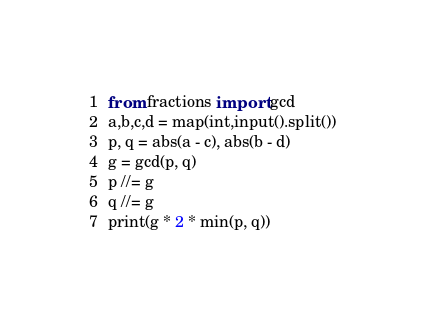<code> <loc_0><loc_0><loc_500><loc_500><_Python_>from fractions import gcd
a,b,c,d = map(int,input().split())
p, q = abs(a - c), abs(b - d)
g = gcd(p, q)
p //= g
q //= g
print(g * 2 * min(p, q))</code> 